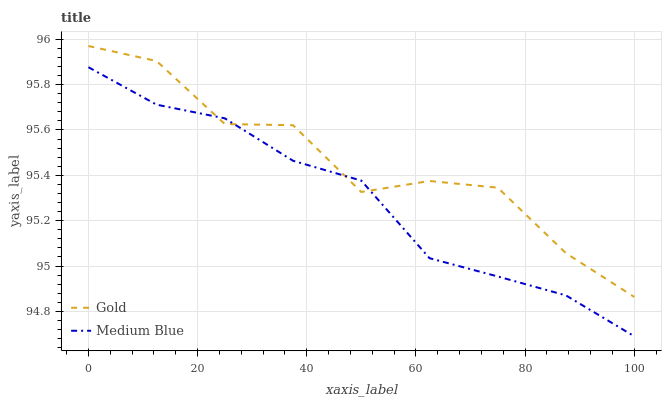Does Medium Blue have the minimum area under the curve?
Answer yes or no. Yes. Does Gold have the maximum area under the curve?
Answer yes or no. Yes. Does Gold have the minimum area under the curve?
Answer yes or no. No. Is Medium Blue the smoothest?
Answer yes or no. Yes. Is Gold the roughest?
Answer yes or no. Yes. Is Gold the smoothest?
Answer yes or no. No. Does Gold have the lowest value?
Answer yes or no. No. 